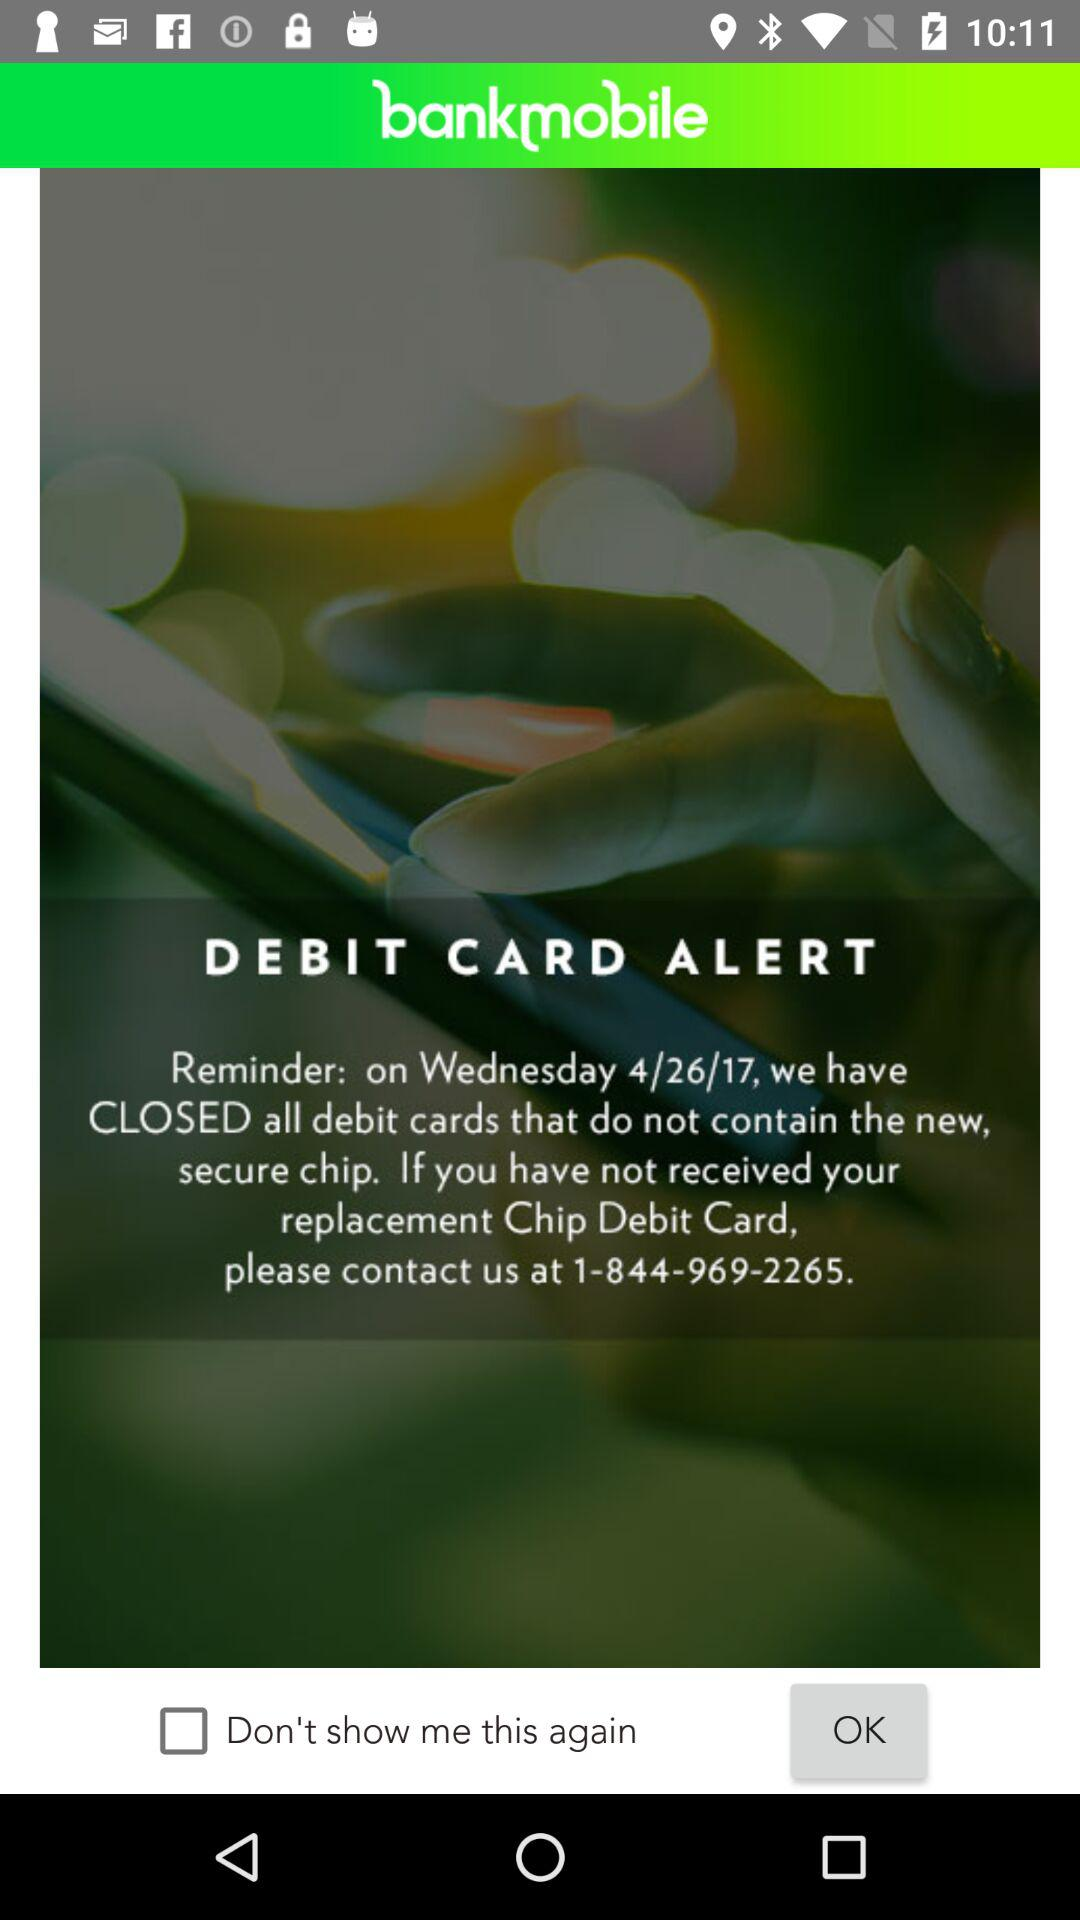Which cards will be available in replacement of debit card? The card will be a chip debit card. 